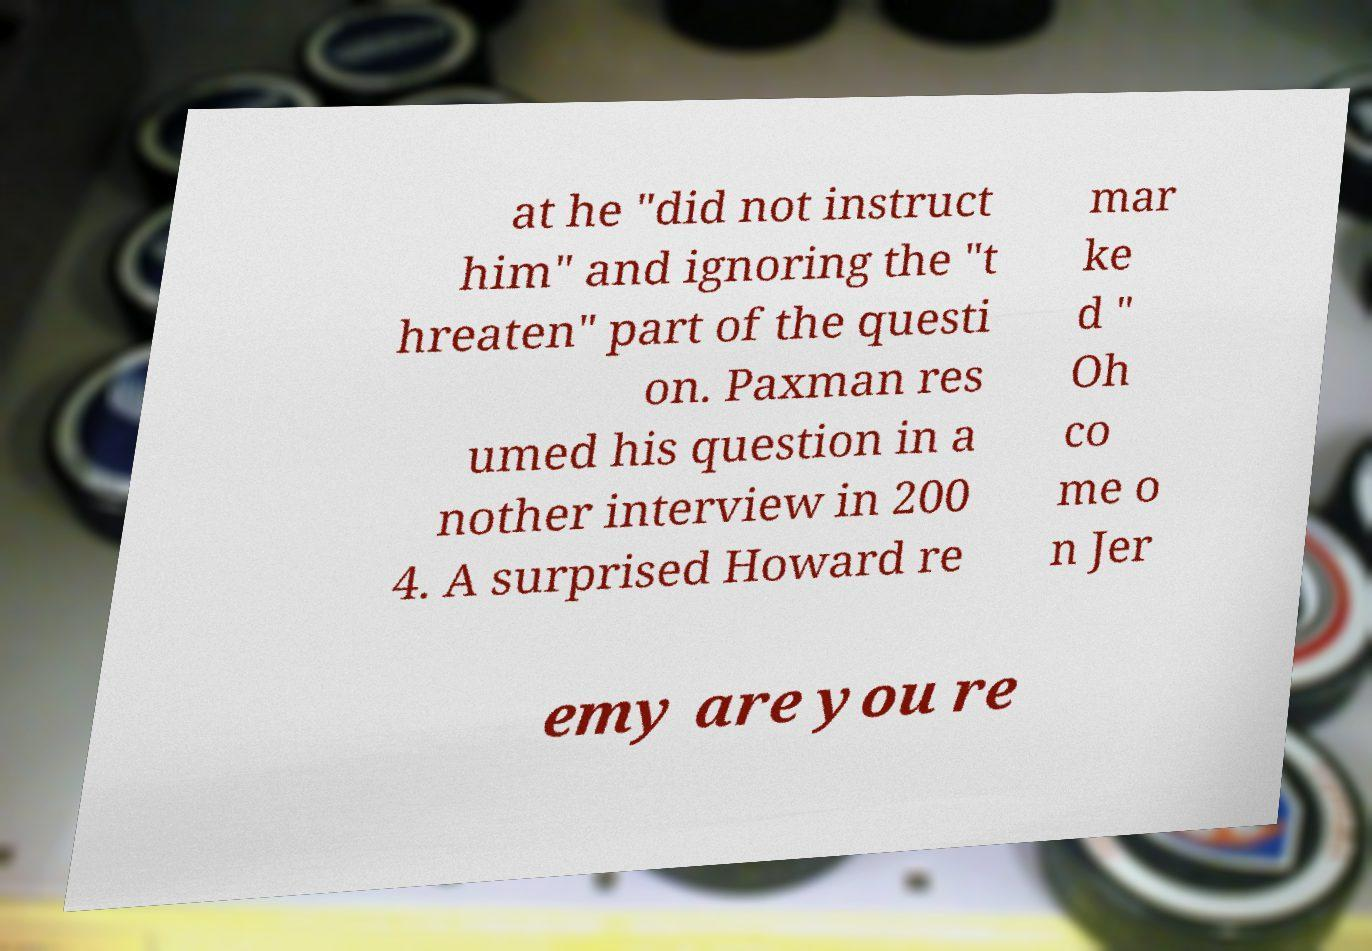Can you read and provide the text displayed in the image?This photo seems to have some interesting text. Can you extract and type it out for me? at he "did not instruct him" and ignoring the "t hreaten" part of the questi on. Paxman res umed his question in a nother interview in 200 4. A surprised Howard re mar ke d " Oh co me o n Jer emy are you re 